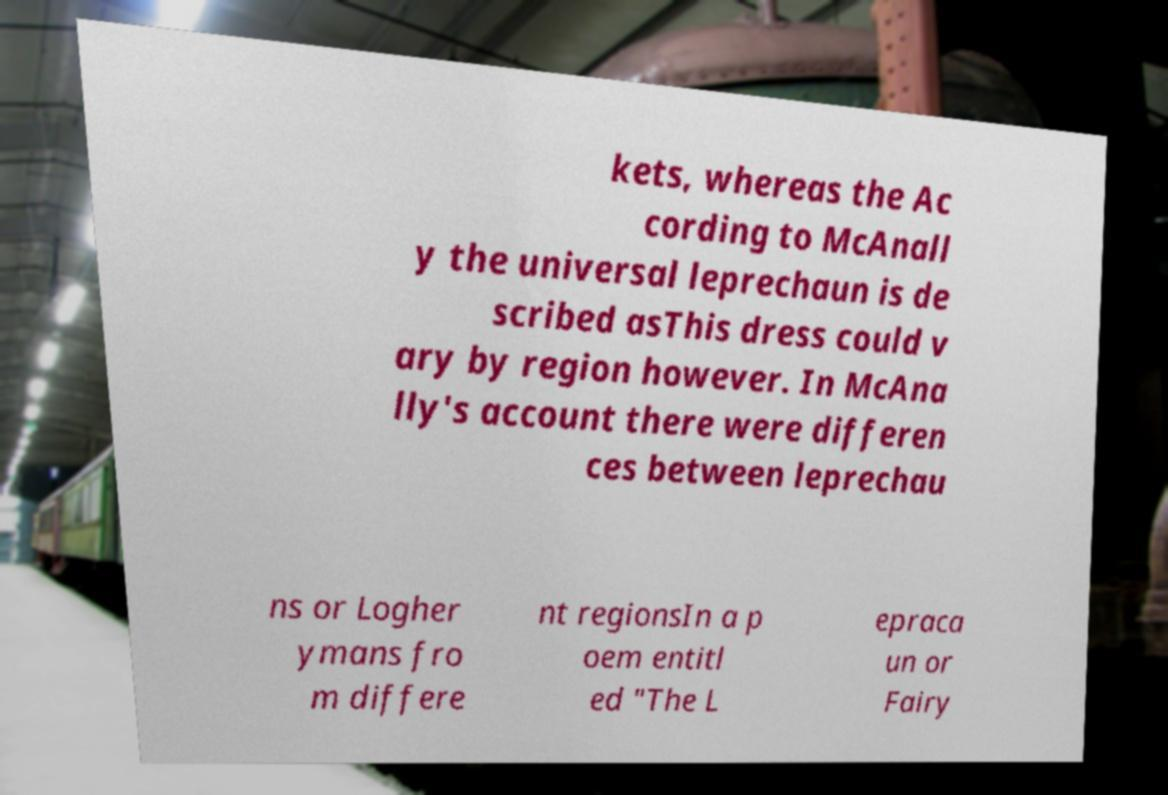Please identify and transcribe the text found in this image. kets, whereas the Ac cording to McAnall y the universal leprechaun is de scribed asThis dress could v ary by region however. In McAna lly's account there were differen ces between leprechau ns or Logher ymans fro m differe nt regionsIn a p oem entitl ed "The L epraca un or Fairy 